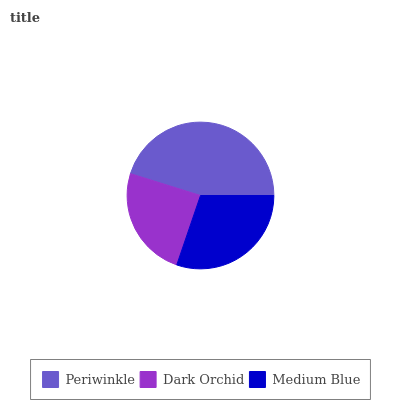Is Dark Orchid the minimum?
Answer yes or no. Yes. Is Periwinkle the maximum?
Answer yes or no. Yes. Is Medium Blue the minimum?
Answer yes or no. No. Is Medium Blue the maximum?
Answer yes or no. No. Is Medium Blue greater than Dark Orchid?
Answer yes or no. Yes. Is Dark Orchid less than Medium Blue?
Answer yes or no. Yes. Is Dark Orchid greater than Medium Blue?
Answer yes or no. No. Is Medium Blue less than Dark Orchid?
Answer yes or no. No. Is Medium Blue the high median?
Answer yes or no. Yes. Is Medium Blue the low median?
Answer yes or no. Yes. Is Dark Orchid the high median?
Answer yes or no. No. Is Dark Orchid the low median?
Answer yes or no. No. 